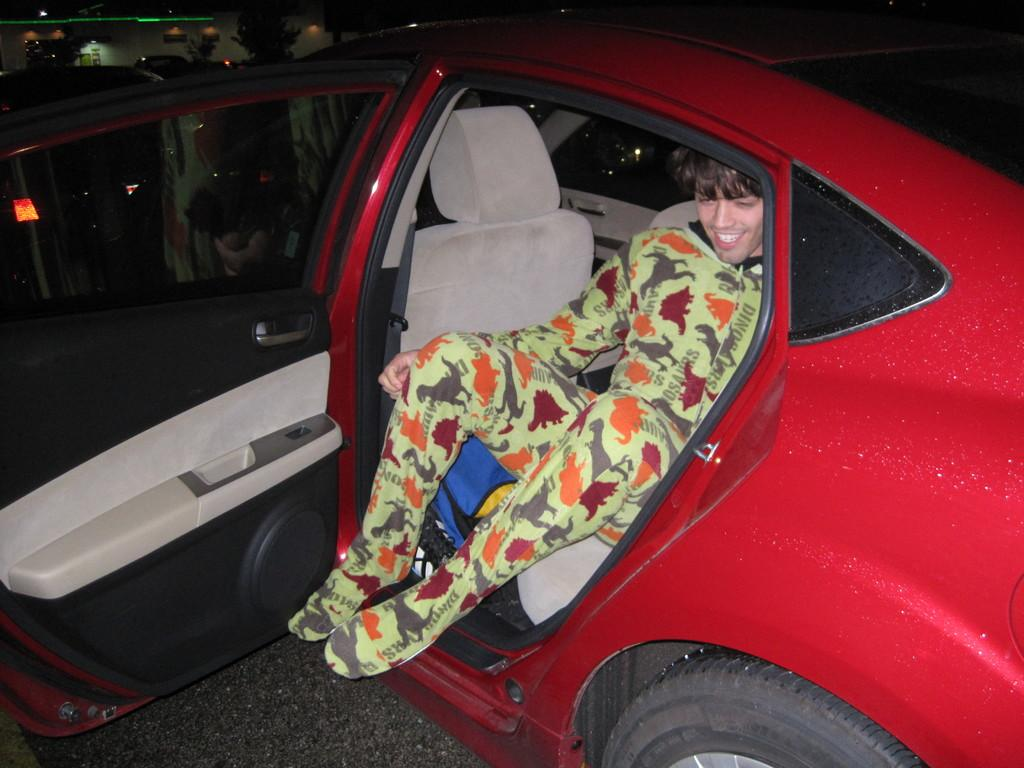What is the person in the image doing? There is a person sitting inside a car in the image. How is the car positioned in the image? The car is placed on the ground. What can be seen in the background of the image? There are trees and a building in the background of the image. Is there an oven visible in the image? No, there is no oven present in the image. 